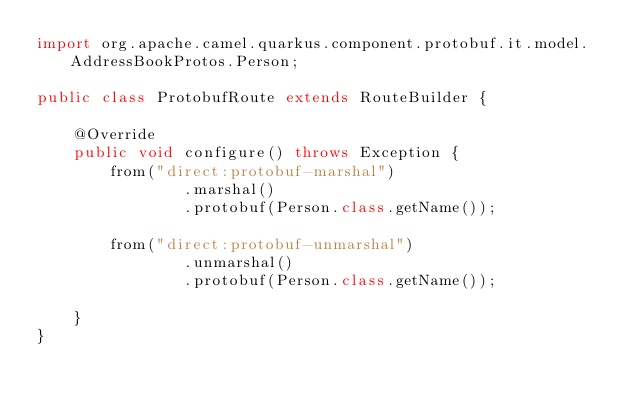Convert code to text. <code><loc_0><loc_0><loc_500><loc_500><_Java_>import org.apache.camel.quarkus.component.protobuf.it.model.AddressBookProtos.Person;

public class ProtobufRoute extends RouteBuilder {

    @Override
    public void configure() throws Exception {
        from("direct:protobuf-marshal")
                .marshal()
                .protobuf(Person.class.getName());

        from("direct:protobuf-unmarshal")
                .unmarshal()
                .protobuf(Person.class.getName());

    }
}
</code> 